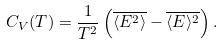<formula> <loc_0><loc_0><loc_500><loc_500>C _ { V } ( T ) = \frac { 1 } { T ^ { 2 } } \left ( \overline { \langle E ^ { 2 } \rangle } - \overline { \langle E \rangle ^ { 2 } } \right ) .</formula> 